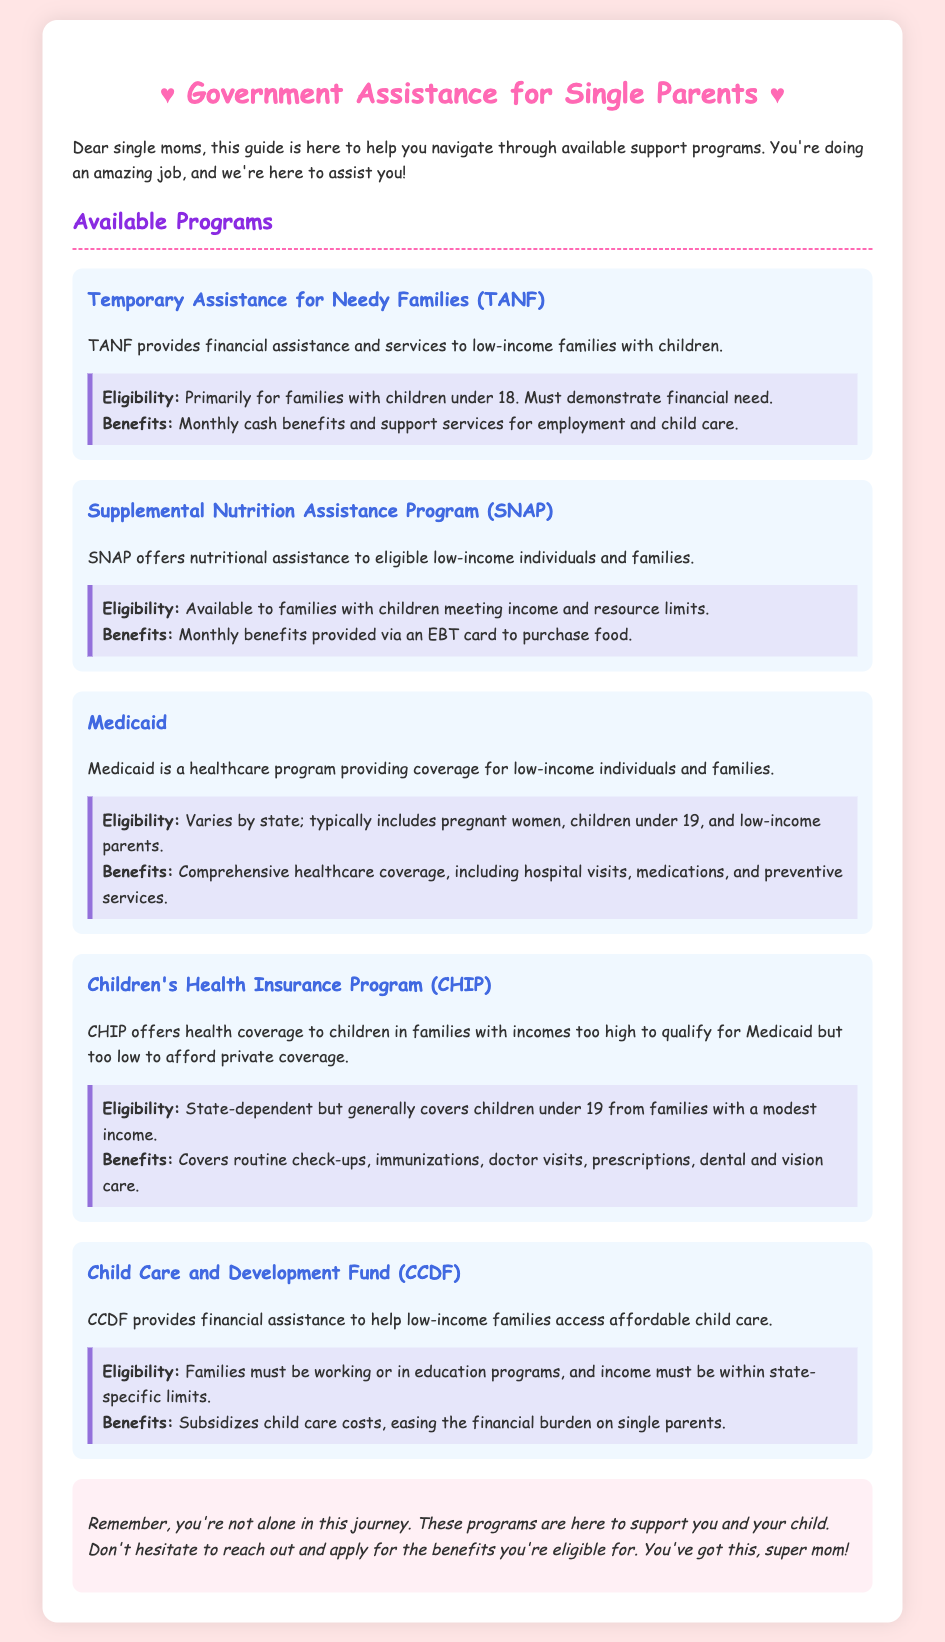What is TANF? TANF stands for Temporary Assistance for Needy Families, which provides financial assistance to low-income families with children.
Answer: Temporary Assistance for Needy Families What is the eligibility for SNAP? The eligibility for SNAP is available to families with children meeting income and resource limits.
Answer: Families with children meeting income and resource limits What benefits does Medicaid provide? Medicaid provides comprehensive healthcare coverage, including hospital visits, medications, and preventive services.
Answer: Comprehensive healthcare coverage What is the age limit for CHIP coverage? CHIP covers children under 19.
Answer: Under 19 What does the Child Care and Development Fund assist with? The Child Care and Development Fund assists with subsidizing child care costs for low-income families.
Answer: Subsidizing child care costs What is required for CCDF eligibility? For CCDF eligibility, families must be working or in education programs, and income must be within state-specific limits.
Answer: Working or in education programs What type of assistance does SNAP offer? SNAP offers nutritional assistance to eligible low-income individuals and families.
Answer: Nutritional assistance Which program provides financial assistance for child care? The Child Care and Development Fund provides financial assistance for child care.
Answer: Child Care and Development Fund What is the conclusion of the document? The conclusion encourages single parents to apply for benefits and reassures them they're not alone.
Answer: You're not alone in this journey 